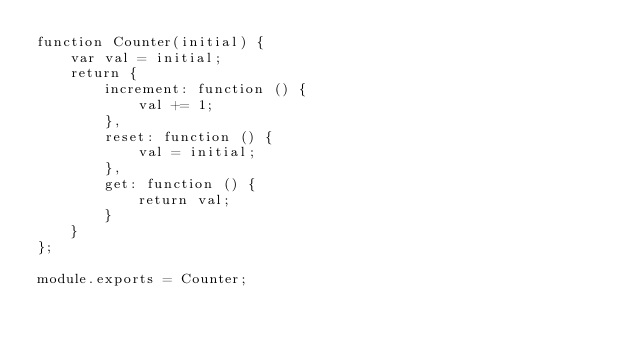<code> <loc_0><loc_0><loc_500><loc_500><_JavaScript_>function Counter(initial) {
    var val = initial;
    return {
        increment: function () {
            val += 1;
        },
        reset: function () {
            val = initial;
        },
        get: function () {
            return val;
        }
    }
};

module.exports = Counter;
</code> 